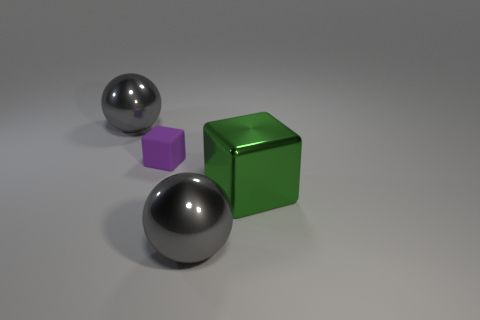Add 1 large shiny objects. How many objects exist? 5 Subtract all large green objects. Subtract all gray shiny spheres. How many objects are left? 1 Add 2 small purple blocks. How many small purple blocks are left? 3 Add 4 small cyan rubber cubes. How many small cyan rubber cubes exist? 4 Subtract 0 blue cylinders. How many objects are left? 4 